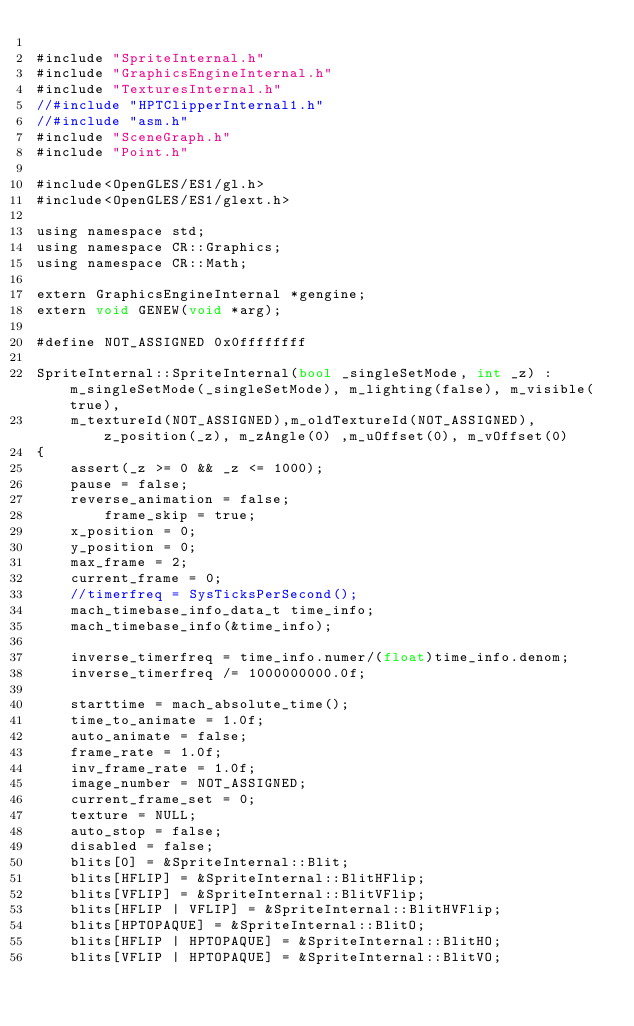Convert code to text. <code><loc_0><loc_0><loc_500><loc_500><_ObjectiveC_>
#include "SpriteInternal.h"
#include "GraphicsEngineInternal.h"
#include "TexturesInternal.h"
//#include "HPTClipperInternal1.h"
//#include "asm.h"
#include "SceneGraph.h"
#include "Point.h"

#include<OpenGLES/ES1/gl.h>
#include<OpenGLES/ES1/glext.h>

using namespace std;
using namespace CR::Graphics;
using namespace CR::Math;

extern GraphicsEngineInternal *gengine;
extern void GENEW(void *arg);

#define NOT_ASSIGNED 0x0ffffffff

SpriteInternal::SpriteInternal(bool _singleSetMode, int _z) : m_singleSetMode(_singleSetMode), m_lighting(false), m_visible(true),
	m_textureId(NOT_ASSIGNED),m_oldTextureId(NOT_ASSIGNED), z_position(_z), m_zAngle(0) ,m_uOffset(0), m_vOffset(0)
{
	assert(_z >= 0 && _z <= 1000);
	pause = false;
	reverse_animation = false;
		frame_skip = true;
	x_position = 0;
	y_position = 0;
	max_frame = 2;
	current_frame = 0;
	//timerfreq = SysTicksPerSecond();
	mach_timebase_info_data_t time_info;
	mach_timebase_info(&time_info);

	inverse_timerfreq = time_info.numer/(float)time_info.denom;
	inverse_timerfreq /= 1000000000.0f;
	
	starttime = mach_absolute_time();
	time_to_animate = 1.0f;
	auto_animate = false;
	frame_rate = 1.0f;
	inv_frame_rate = 1.0f;
	image_number = NOT_ASSIGNED;
	current_frame_set = 0;
	texture = NULL;
	auto_stop = false;
	disabled = false;
	blits[0] = &SpriteInternal::Blit;
	blits[HFLIP] = &SpriteInternal::BlitHFlip;
	blits[VFLIP] = &SpriteInternal::BlitVFlip;
	blits[HFLIP | VFLIP] = &SpriteInternal::BlitHVFlip;
	blits[HPTOPAQUE] = &SpriteInternal::BlitO;
	blits[HFLIP | HPTOPAQUE] = &SpriteInternal::BlitHO;
	blits[VFLIP | HPTOPAQUE] = &SpriteInternal::BlitVO;</code> 